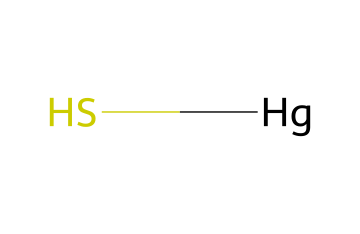What is the name of this compound? The SMILES representation indicates the presence of mercury and sulfur atoms. Given their composition, this chemical is commonly known as cinnabar or mercuric sulfide.
Answer: cinnabar How many sulfur atoms are present in this compound? The SMILES notation shows one sulfur atom connected to mercury, indicating the total count is one.
Answer: one What is the oxidation state of mercury in this compound? In cinnabar, mercury is in a +2 oxidation state as it forms a binary compound with sulfur, which typically has a -2 oxidation state.
Answer: +2 What type of bond is formed between the mercury and sulfur atoms? The molecule consists of a metal (mercury) and a non-metal (sulfur), suggesting a polar covalent bond due to the difference in electronegativity.
Answer: polar covalent What is the molecular formula of this compound? The composition based on the SMILES indicates one mercury and one sulfur atom, leading to the molecular formula HgS.
Answer: HgS What is a common use of cinnabar in traditional practices? Historically, cinnabar has been used as a pigment due to its vibrant red color, often in artwork and decorative applications.
Answer: pigment 